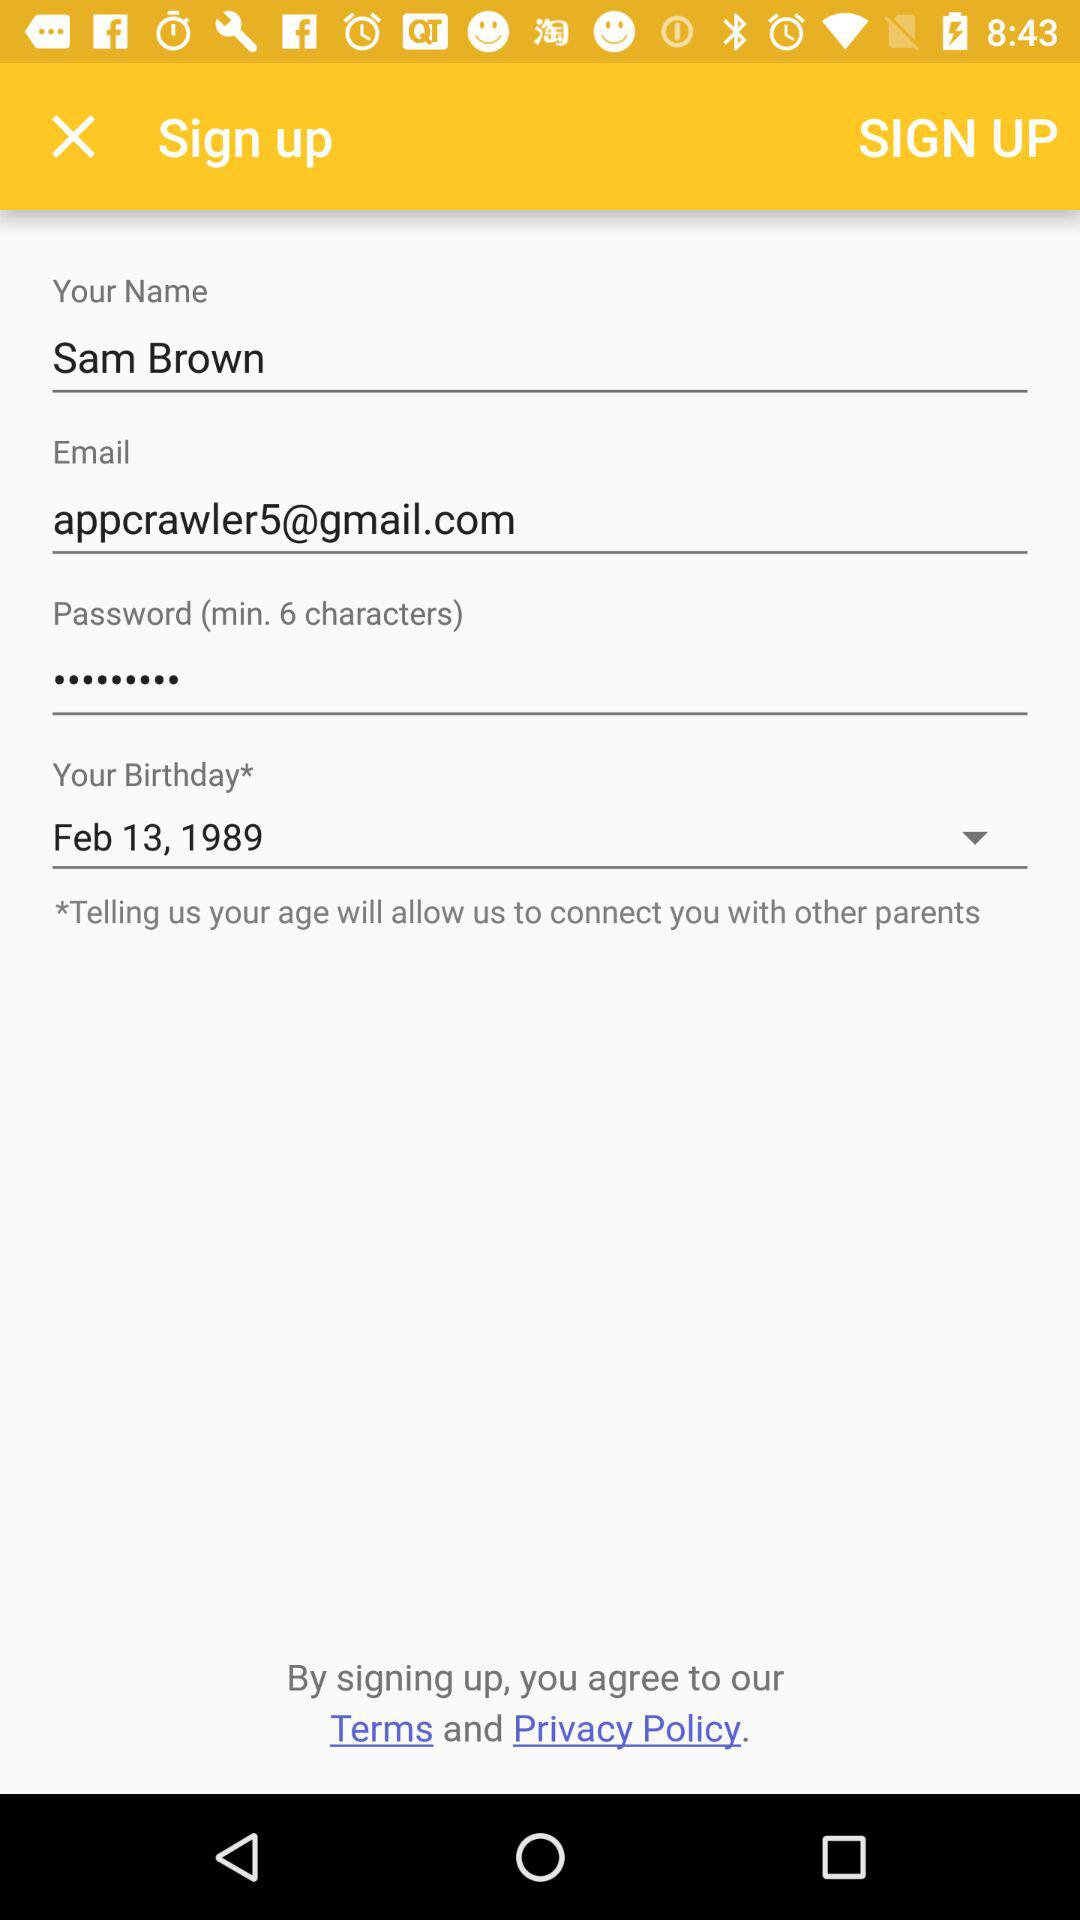What is the date of birth? The date of birth is February 13, 1989. 